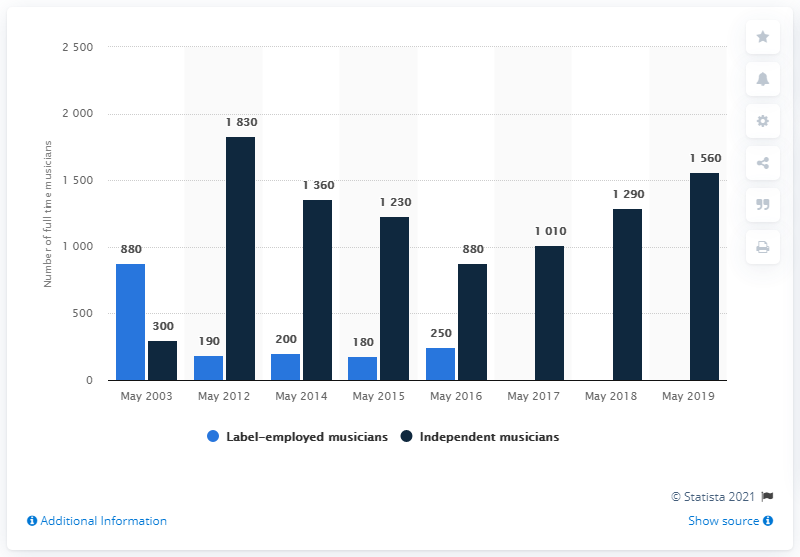Identify some key points in this picture. The average number of independent musicians in the United States from 2003 to 2012 was 1065. There were approximately 300 independent musicians in the United States in 2003. 